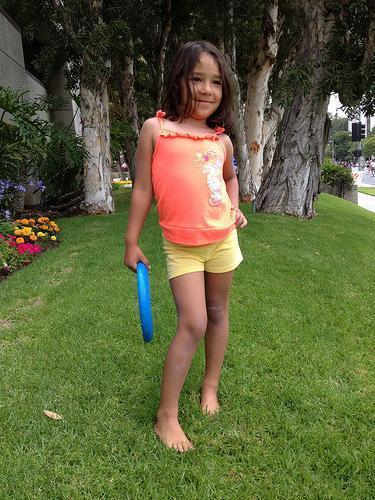How many people are in the picture?
Give a very brief answer. 1. 